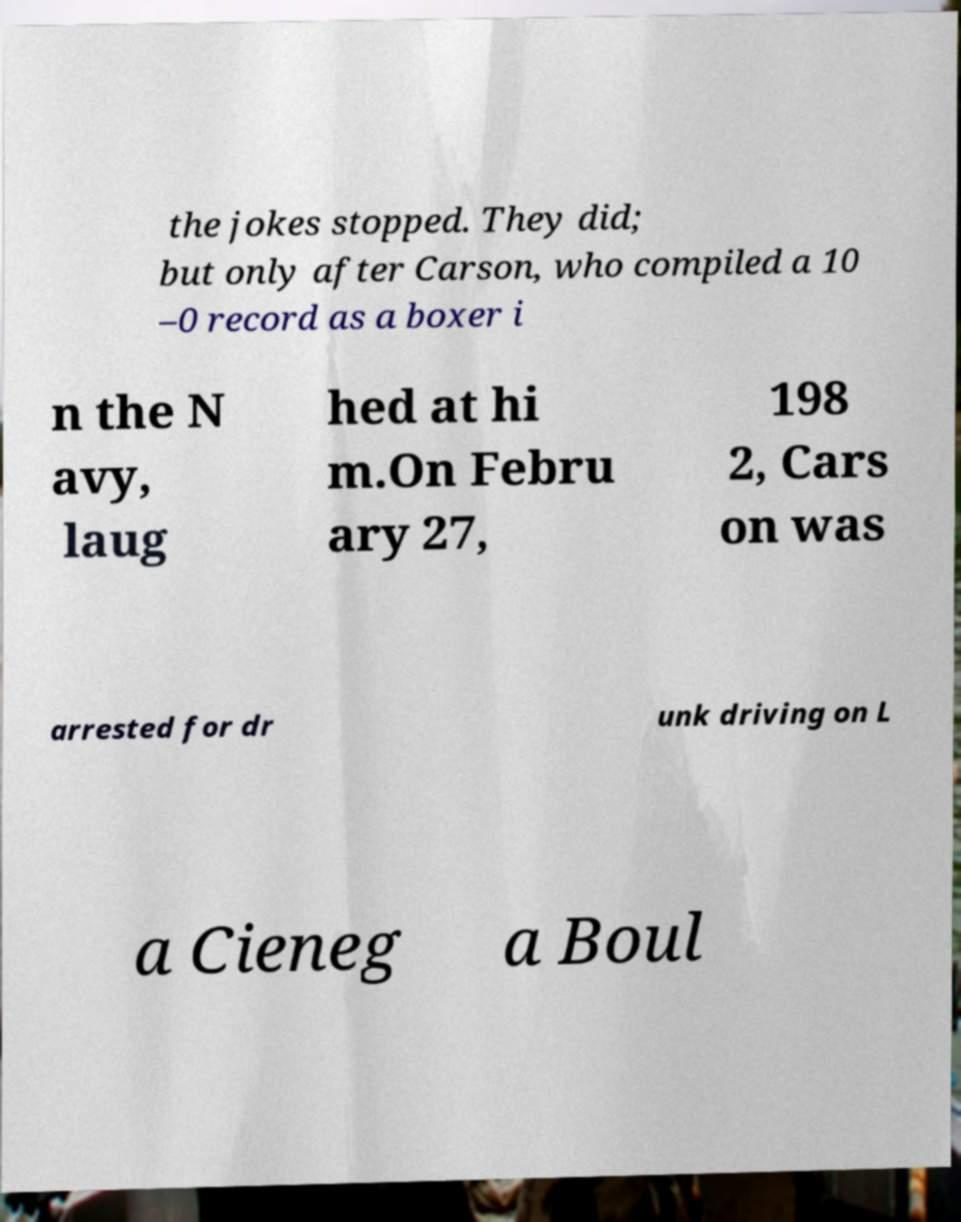Could you assist in decoding the text presented in this image and type it out clearly? the jokes stopped. They did; but only after Carson, who compiled a 10 –0 record as a boxer i n the N avy, laug hed at hi m.On Febru ary 27, 198 2, Cars on was arrested for dr unk driving on L a Cieneg a Boul 